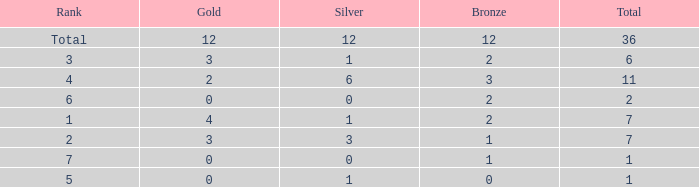What is the largest total for a team with 1 bronze, 0 gold medals and ranking of 7? None. 